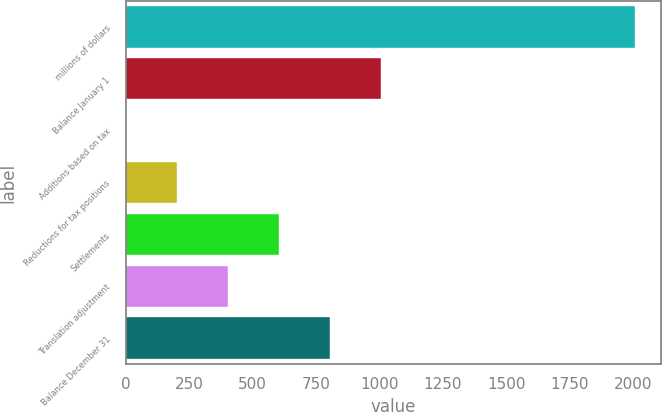Convert chart to OTSL. <chart><loc_0><loc_0><loc_500><loc_500><bar_chart><fcel>millions of dollars<fcel>Balance January 1<fcel>Additions based on tax<fcel>Reductions for tax positions<fcel>Settlements<fcel>Translation adjustment<fcel>Balance December 31<nl><fcel>2008<fcel>1004.25<fcel>0.5<fcel>201.25<fcel>602.75<fcel>402<fcel>803.5<nl></chart> 